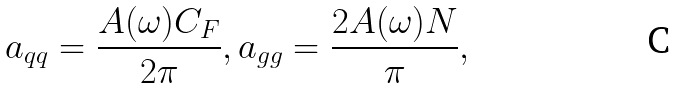Convert formula to latex. <formula><loc_0><loc_0><loc_500><loc_500>a _ { q q } = \frac { A ( \omega ) C _ { F } } { 2 \pi } , a _ { g g } = \frac { 2 A ( \omega ) N } { \pi } ,</formula> 